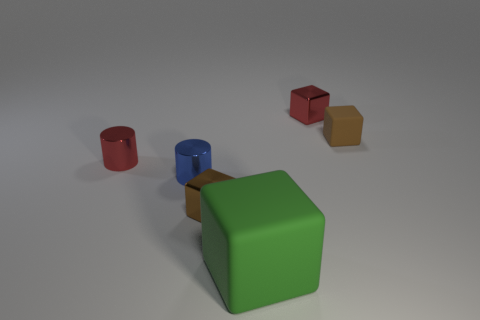Are there any other things that are the same size as the green rubber cube?
Provide a succinct answer. No. Do the large green cube and the red object right of the green matte thing have the same material?
Give a very brief answer. No. There is a matte thing on the left side of the red metal thing that is to the right of the big green matte cube; what shape is it?
Your response must be concise. Cube. Is the color of the tiny rubber thing the same as the small object in front of the blue object?
Your answer should be compact. Yes. The large object has what shape?
Your answer should be compact. Cube. What is the size of the rubber thing that is in front of the tiny metallic object left of the tiny blue thing?
Give a very brief answer. Large. Are there the same number of green things in front of the big green rubber thing and things behind the blue thing?
Offer a very short reply. No. There is a tiny cube that is on the left side of the brown matte thing and behind the red metal cylinder; what is its material?
Provide a short and direct response. Metal. There is a blue metal object; does it have the same size as the green matte cube that is right of the blue object?
Your response must be concise. No. How many other things are there of the same color as the tiny rubber block?
Provide a short and direct response. 1. 